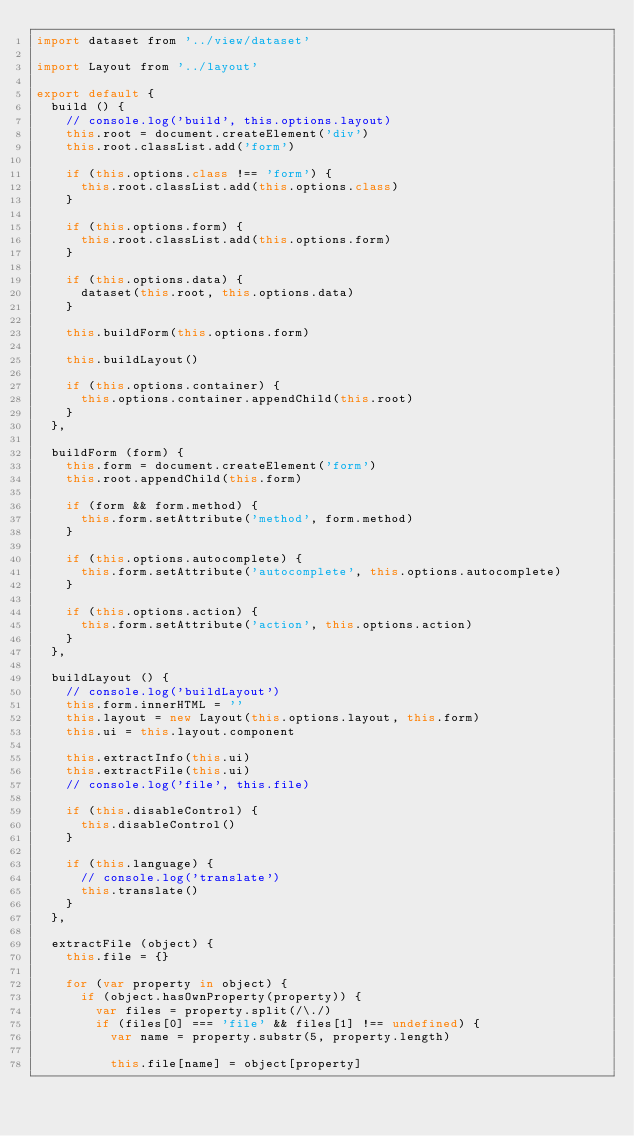Convert code to text. <code><loc_0><loc_0><loc_500><loc_500><_JavaScript_>import dataset from '../view/dataset'

import Layout from '../layout'

export default {
  build () {
    // console.log('build', this.options.layout)
    this.root = document.createElement('div')
    this.root.classList.add('form')

    if (this.options.class !== 'form') {
      this.root.classList.add(this.options.class)
    }

    if (this.options.form) {
      this.root.classList.add(this.options.form)
    }

    if (this.options.data) {
      dataset(this.root, this.options.data)
    }

    this.buildForm(this.options.form)

    this.buildLayout()

    if (this.options.container) {
      this.options.container.appendChild(this.root)
    }
  },

  buildForm (form) {
    this.form = document.createElement('form')
    this.root.appendChild(this.form)

    if (form && form.method) {
      this.form.setAttribute('method', form.method)
    }

    if (this.options.autocomplete) {
      this.form.setAttribute('autocomplete', this.options.autocomplete)
    }

    if (this.options.action) {
      this.form.setAttribute('action', this.options.action)
    }
  },

  buildLayout () {
    // console.log('buildLayout')
    this.form.innerHTML = ''
    this.layout = new Layout(this.options.layout, this.form)
    this.ui = this.layout.component

    this.extractInfo(this.ui)
    this.extractFile(this.ui)
    // console.log('file', this.file)

    if (this.disableControl) {
      this.disableControl()
    }

    if (this.language) {
      // console.log('translate')
      this.translate()
    }
  },

  extractFile (object) {
    this.file = {}

    for (var property in object) {
      if (object.hasOwnProperty(property)) {
        var files = property.split(/\./)
        if (files[0] === 'file' && files[1] !== undefined) {
          var name = property.substr(5, property.length)

          this.file[name] = object[property]</code> 